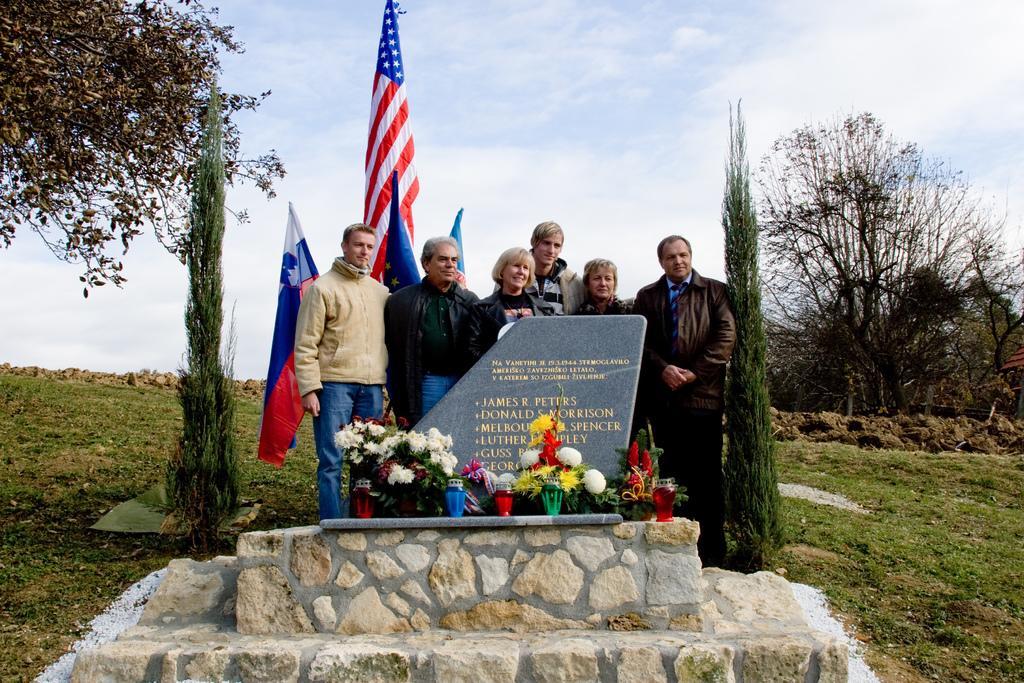How would you summarize this image in a sentence or two? In this image I can see few people are standing in front of the memorial. I can see few trees, flags, colorful flowers and the sky is in blue and white color. 